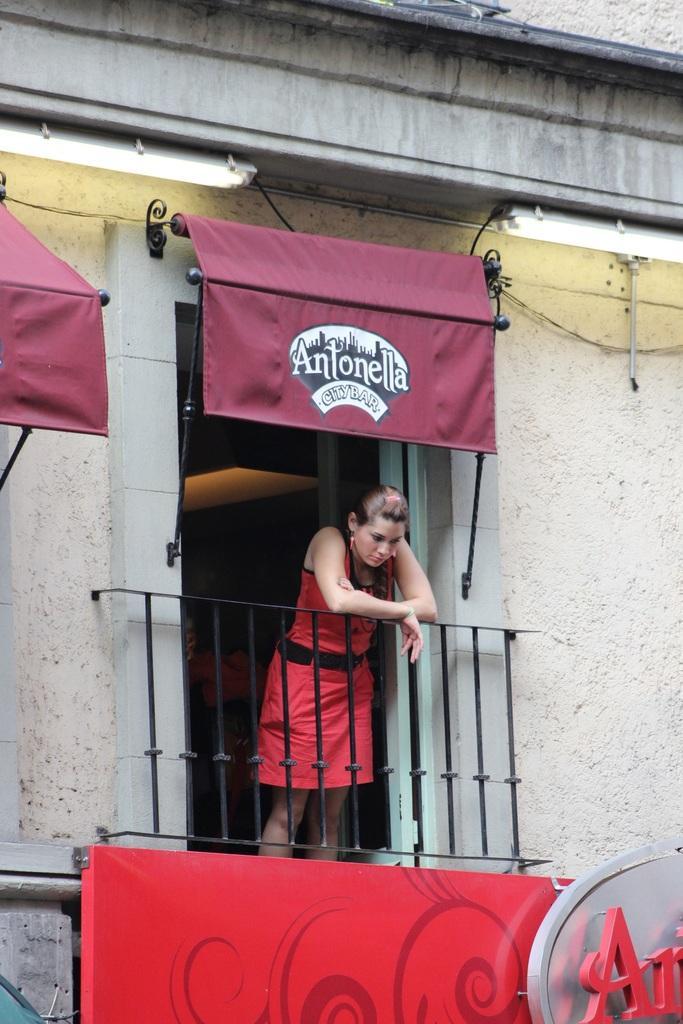In one or two sentences, can you explain what this image depicts? In this image we can see a woman standing and seeing down through a railing. In the background we can see building and a pipeline. 